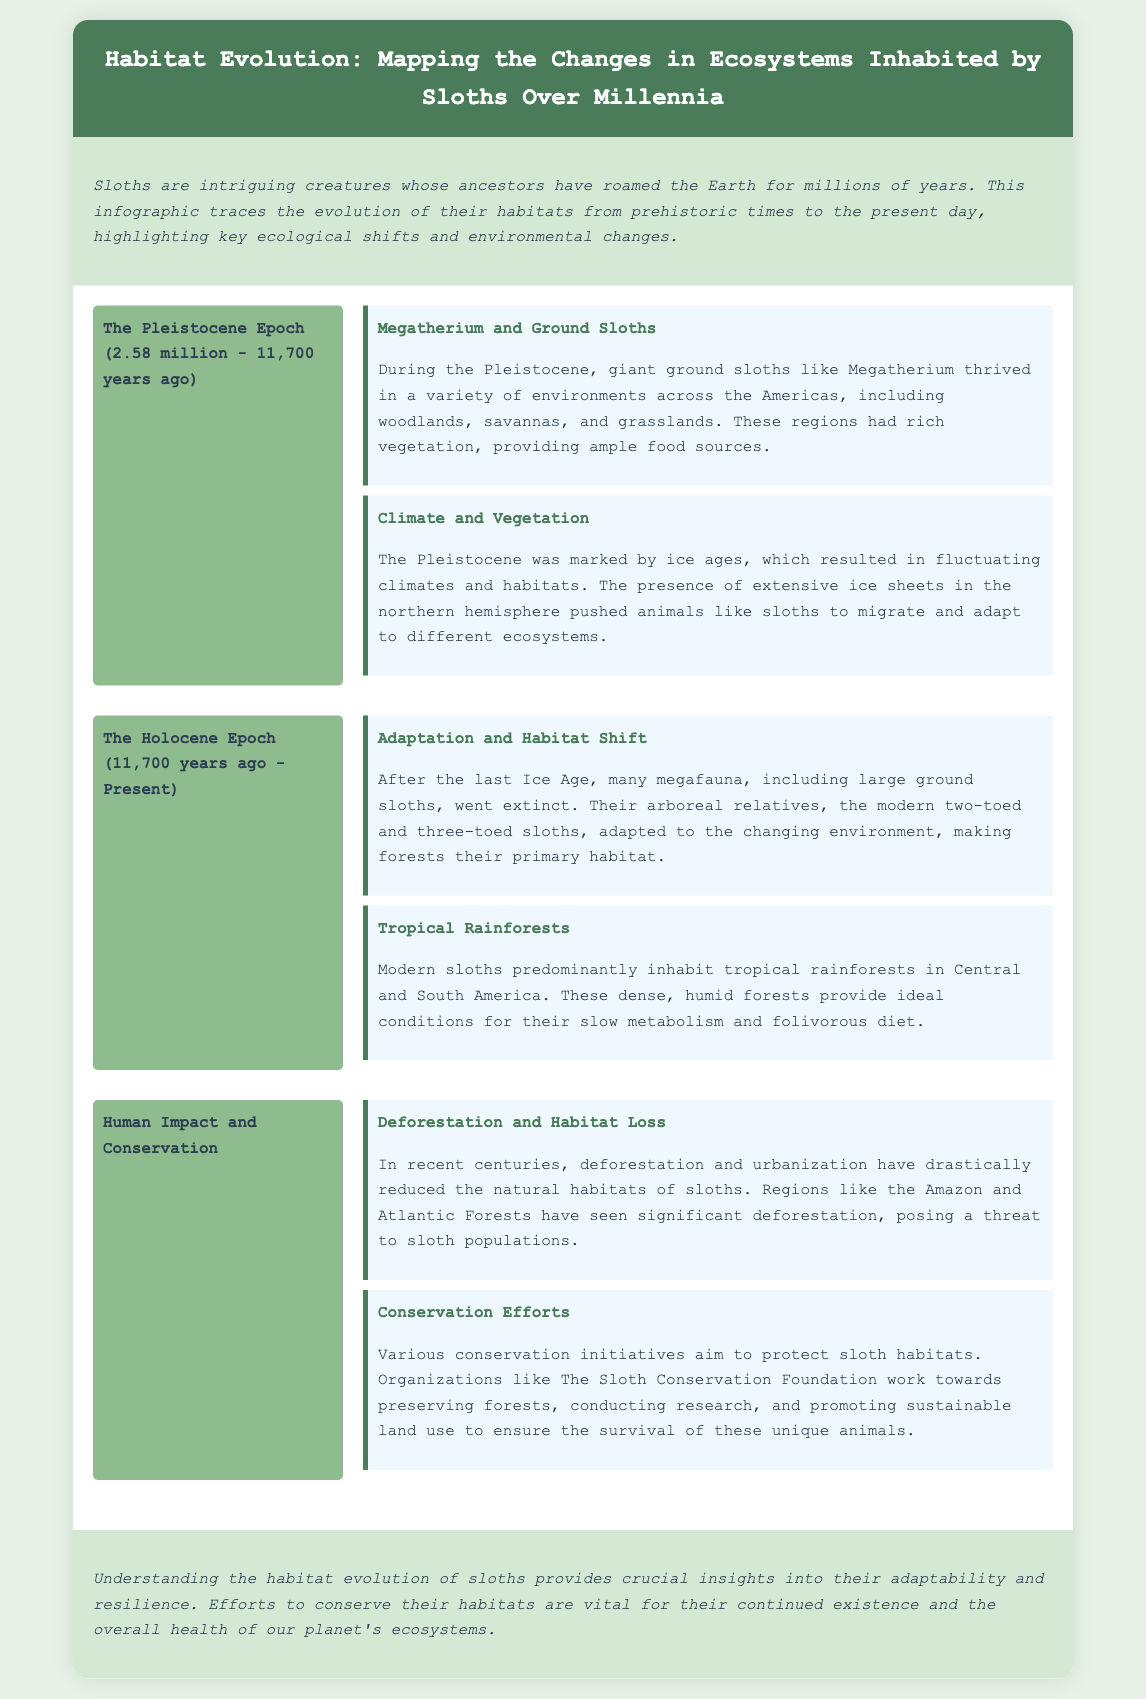What epoch spans from 2.58 million to 11,700 years ago? The Pleistocene Epoch is the time frame mentioned in the document for this period.
Answer: The Pleistocene Epoch Who thrived during the Pleistocene in various environments? The document indicates that Megatherium and ground sloths thrived during the Pleistocene.
Answer: Megatherium and ground sloths What habitat did modern sloths adapt to after the last Ice Age? The document states that modern sloths made forests their primary habitat following the last Ice Age.
Answer: Forests What main habitat do modern sloths inhabit? The document mentions that modern sloths predominantly inhabit tropical rainforests.
Answer: Tropical rainforests What has significantly reduced sloth habitats in recent centuries? The document notes that deforestation and urbanization have drastically reduced sloth habitats.
Answer: Deforestation and urbanization Which organization mentioned works towards preserving sloth habitats? According to the document, The Sloth Conservation Foundation works on habitat preservation.
Answer: The Sloth Conservation Foundation What period follows the Pleistocene in the sloth habitat evolution? The Holocene Epoch follows the Pleistocene as stated in the document.
Answer: The Holocene Epoch How do conservation efforts impact sloth habitats? The document suggests that conservation efforts aim to protect sloth habitats, which indicates a positive impact.
Answer: Protect sloth habitats 